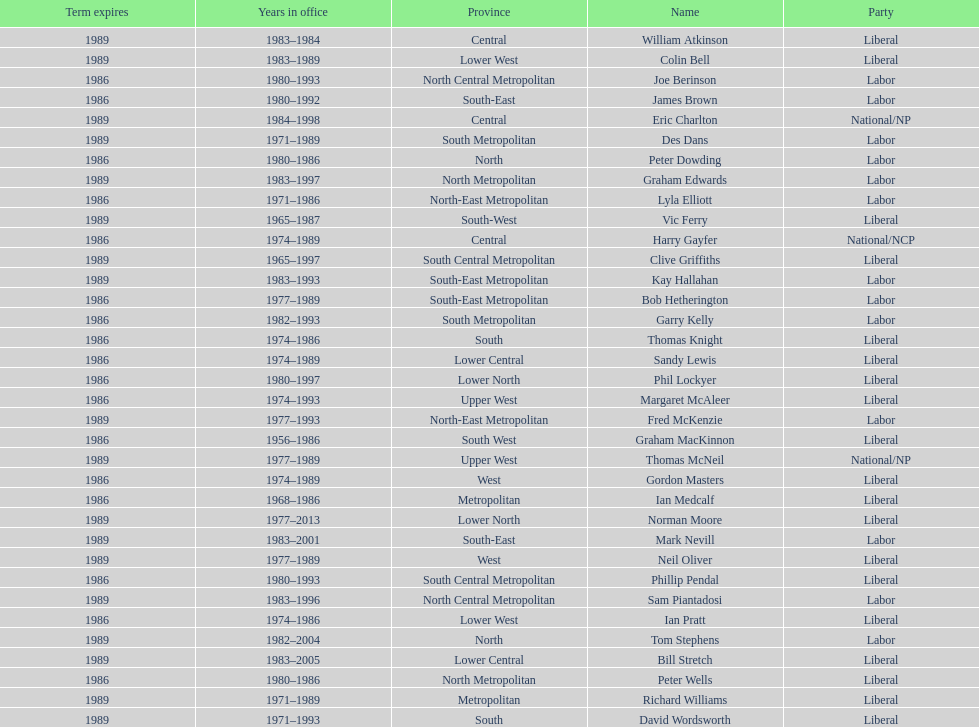State the most recent member listed with a family name beginning with "p". Ian Pratt. 